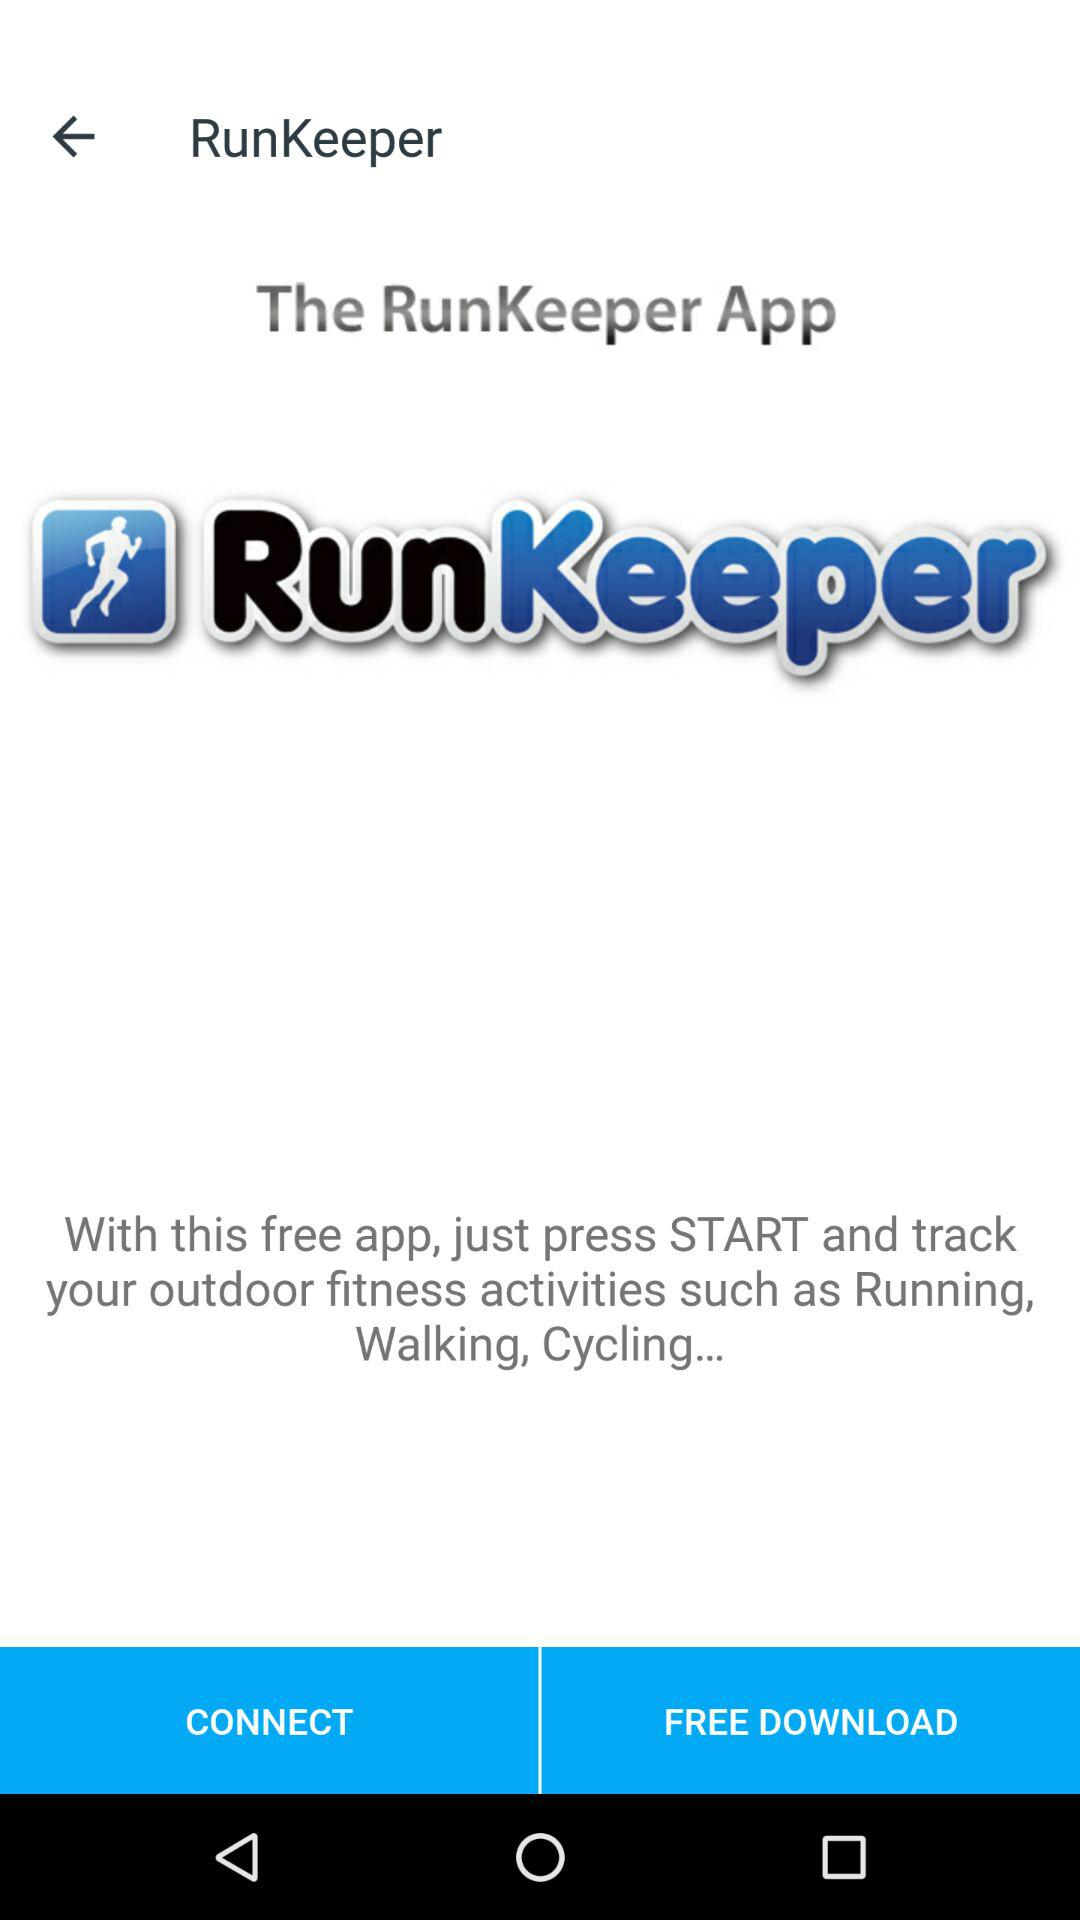What’s the app name? The app name is "RunKeeper". 